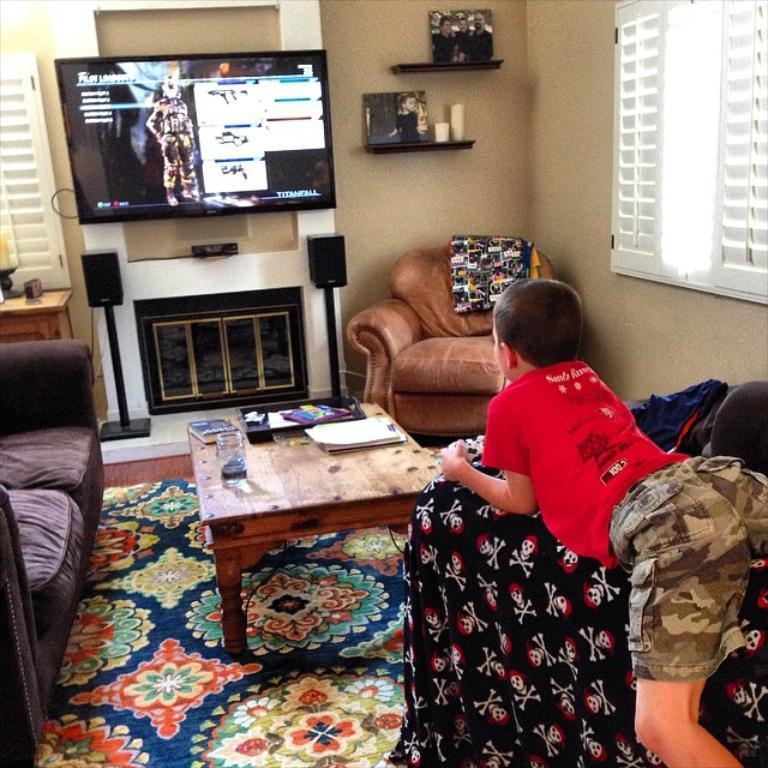Describe this image in one or two sentences. This is a picture taken in a room. The boy in red t shirt lying on a couch. In front of the man there is a table on the table there is a glass, book and papers. In front of the table there is a television on the wall with a shelf. 